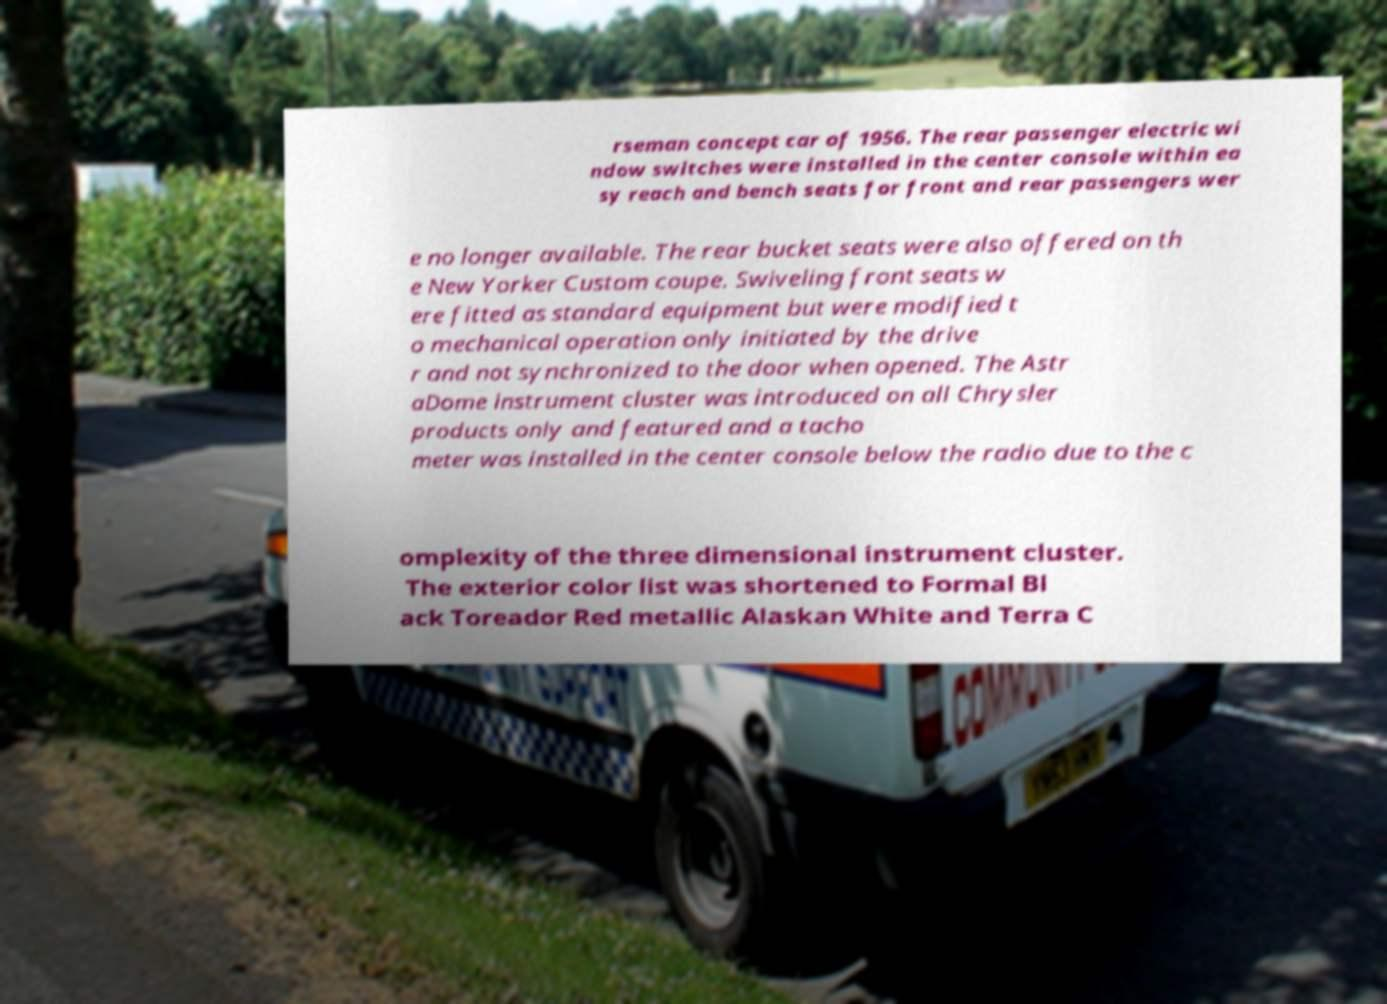Can you read and provide the text displayed in the image?This photo seems to have some interesting text. Can you extract and type it out for me? rseman concept car of 1956. The rear passenger electric wi ndow switches were installed in the center console within ea sy reach and bench seats for front and rear passengers wer e no longer available. The rear bucket seats were also offered on th e New Yorker Custom coupe. Swiveling front seats w ere fitted as standard equipment but were modified t o mechanical operation only initiated by the drive r and not synchronized to the door when opened. The Astr aDome instrument cluster was introduced on all Chrysler products only and featured and a tacho meter was installed in the center console below the radio due to the c omplexity of the three dimensional instrument cluster. The exterior color list was shortened to Formal Bl ack Toreador Red metallic Alaskan White and Terra C 